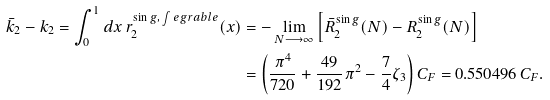<formula> <loc_0><loc_0><loc_500><loc_500>\bar { k } _ { 2 } - k _ { 2 } = \int _ { 0 } ^ { 1 } d x \, r _ { 2 } ^ { \sin g , \, \int e g r a b l e } ( x ) & = - \lim _ { N \longrightarrow \infty } \left [ \bar { R } _ { 2 } ^ { \sin g } ( N ) - R _ { 2 } ^ { \sin g } ( N ) \right ] \\ & = \left ( \frac { \pi ^ { 4 } } { 7 2 0 } + \frac { 4 9 } { 1 9 2 } \pi ^ { 2 } - \frac { 7 } { 4 } \zeta _ { 3 } \right ) C _ { F } = 0 . 5 5 0 4 9 6 \, C _ { F } .</formula> 